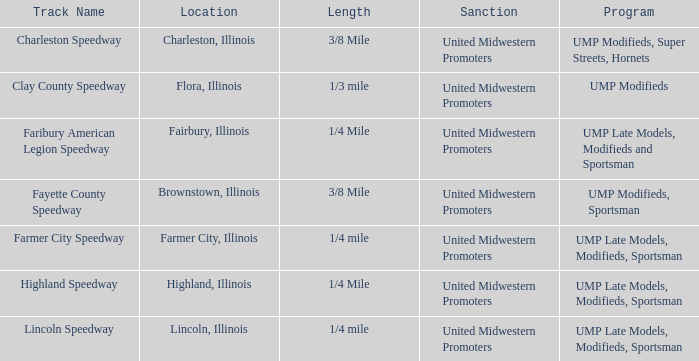Who sanctioned the event at fayette county speedway? United Midwestern Promoters. 